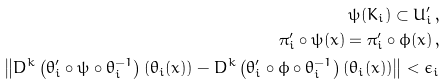<formula> <loc_0><loc_0><loc_500><loc_500>\psi ( K _ { i } ) \subset U ^ { \prime } _ { i } \, , \\ \quad \pi ^ { \prime } _ { i } \circ \psi ( x ) = \pi ^ { \prime } _ { i } \circ \phi ( x ) \, , \\ \left \| D ^ { k } \left ( \theta _ { i } ^ { \prime } \circ \psi \circ \theta _ { i } ^ { - 1 } \right ) ( \theta _ { i } ( x ) ) - D ^ { k } \left ( \theta _ { i } ^ { \prime } \circ \phi \circ \theta _ { i } ^ { - 1 } \right ) ( \theta _ { i } ( x ) ) \right \| < \epsilon _ { i }</formula> 